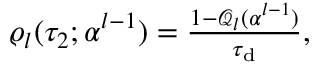Convert formula to latex. <formula><loc_0><loc_0><loc_500><loc_500>\begin{array} { r } { \varrho _ { l } ( \tau _ { 2 } ; \alpha ^ { l - 1 } ) = \frac { 1 - \mathcal { Q } _ { l } ( \alpha ^ { l - 1 } ) } { \tau _ { d } } , } \end{array}</formula> 